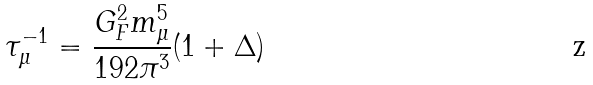Convert formula to latex. <formula><loc_0><loc_0><loc_500><loc_500>\tau _ { \mu } ^ { - 1 } = \frac { G _ { F } ^ { 2 } m _ { \mu } ^ { 5 } } { 1 9 2 \pi ^ { 3 } } ( 1 + \Delta )</formula> 